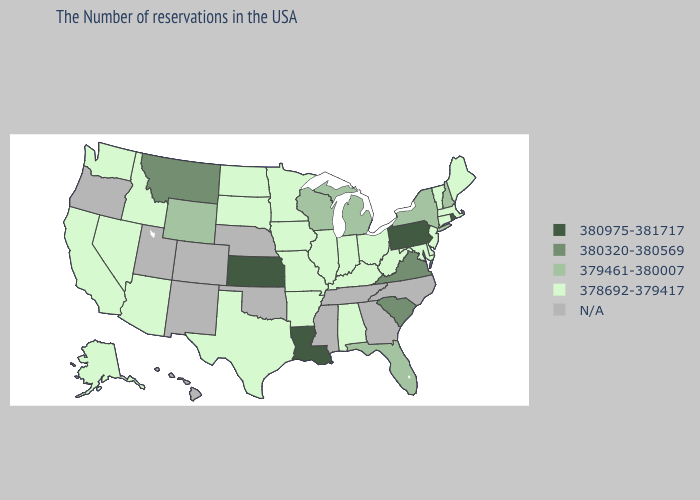Among the states that border Wyoming , which have the lowest value?
Quick response, please. South Dakota, Idaho. What is the highest value in the South ?
Be succinct. 380975-381717. Does the map have missing data?
Quick response, please. Yes. What is the lowest value in states that border Delaware?
Give a very brief answer. 378692-379417. What is the value of West Virginia?
Concise answer only. 378692-379417. What is the value of Minnesota?
Be succinct. 378692-379417. Does the first symbol in the legend represent the smallest category?
Write a very short answer. No. What is the value of North Carolina?
Write a very short answer. N/A. Name the states that have a value in the range 380320-380569?
Write a very short answer. Virginia, South Carolina, Montana. Does Montana have the highest value in the West?
Short answer required. Yes. What is the value of California?
Keep it brief. 378692-379417. What is the highest value in the USA?
Write a very short answer. 380975-381717. What is the lowest value in the Northeast?
Answer briefly. 378692-379417. 